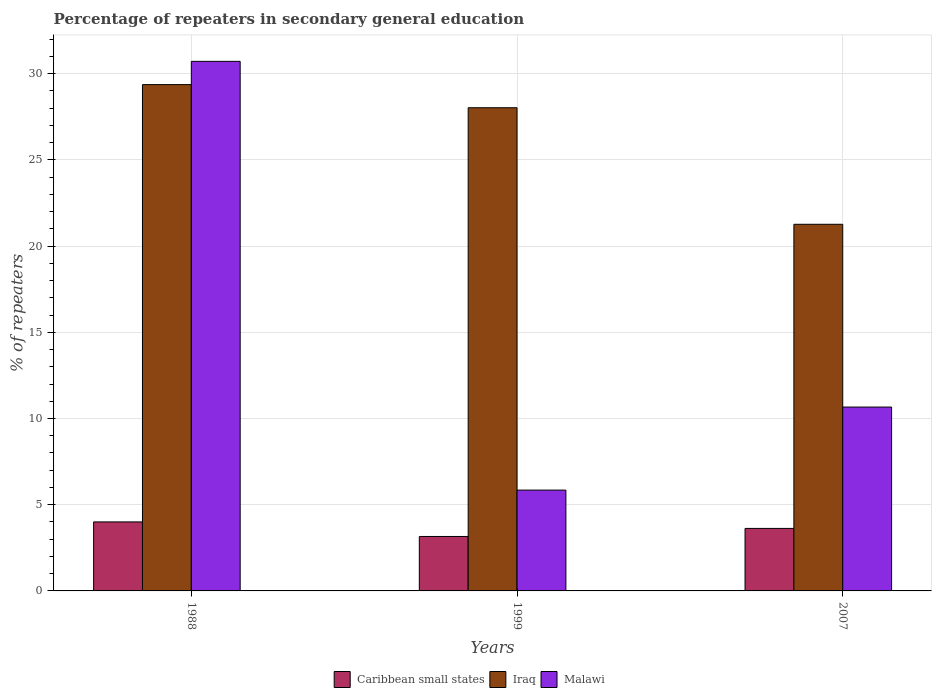Are the number of bars on each tick of the X-axis equal?
Keep it short and to the point. Yes. How many bars are there on the 1st tick from the left?
Make the answer very short. 3. How many bars are there on the 1st tick from the right?
Ensure brevity in your answer.  3. In how many cases, is the number of bars for a given year not equal to the number of legend labels?
Make the answer very short. 0. What is the percentage of repeaters in secondary general education in Iraq in 2007?
Your answer should be compact. 21.26. Across all years, what is the maximum percentage of repeaters in secondary general education in Malawi?
Offer a terse response. 30.71. Across all years, what is the minimum percentage of repeaters in secondary general education in Caribbean small states?
Your response must be concise. 3.16. What is the total percentage of repeaters in secondary general education in Malawi in the graph?
Offer a very short reply. 47.23. What is the difference between the percentage of repeaters in secondary general education in Malawi in 1999 and that in 2007?
Provide a short and direct response. -4.82. What is the difference between the percentage of repeaters in secondary general education in Caribbean small states in 1988 and the percentage of repeaters in secondary general education in Iraq in 1999?
Make the answer very short. -24.02. What is the average percentage of repeaters in secondary general education in Caribbean small states per year?
Offer a very short reply. 3.6. In the year 1988, what is the difference between the percentage of repeaters in secondary general education in Iraq and percentage of repeaters in secondary general education in Malawi?
Offer a very short reply. -1.35. In how many years, is the percentage of repeaters in secondary general education in Iraq greater than 9 %?
Offer a very short reply. 3. What is the ratio of the percentage of repeaters in secondary general education in Caribbean small states in 1988 to that in 2007?
Provide a succinct answer. 1.1. Is the difference between the percentage of repeaters in secondary general education in Iraq in 1988 and 2007 greater than the difference between the percentage of repeaters in secondary general education in Malawi in 1988 and 2007?
Provide a succinct answer. No. What is the difference between the highest and the second highest percentage of repeaters in secondary general education in Malawi?
Your answer should be compact. 20.05. What is the difference between the highest and the lowest percentage of repeaters in secondary general education in Caribbean small states?
Give a very brief answer. 0.84. What does the 1st bar from the left in 2007 represents?
Offer a terse response. Caribbean small states. What does the 1st bar from the right in 1988 represents?
Provide a succinct answer. Malawi. How many bars are there?
Provide a succinct answer. 9. How many years are there in the graph?
Give a very brief answer. 3. Are the values on the major ticks of Y-axis written in scientific E-notation?
Provide a short and direct response. No. Does the graph contain any zero values?
Provide a short and direct response. No. Where does the legend appear in the graph?
Give a very brief answer. Bottom center. How many legend labels are there?
Offer a terse response. 3. How are the legend labels stacked?
Ensure brevity in your answer.  Horizontal. What is the title of the graph?
Your answer should be very brief. Percentage of repeaters in secondary general education. Does "Solomon Islands" appear as one of the legend labels in the graph?
Your answer should be compact. No. What is the label or title of the Y-axis?
Ensure brevity in your answer.  % of repeaters. What is the % of repeaters in Caribbean small states in 1988?
Ensure brevity in your answer.  4. What is the % of repeaters of Iraq in 1988?
Ensure brevity in your answer.  29.37. What is the % of repeaters in Malawi in 1988?
Your answer should be very brief. 30.71. What is the % of repeaters of Caribbean small states in 1999?
Offer a terse response. 3.16. What is the % of repeaters of Iraq in 1999?
Make the answer very short. 28.02. What is the % of repeaters in Malawi in 1999?
Keep it short and to the point. 5.85. What is the % of repeaters in Caribbean small states in 2007?
Provide a succinct answer. 3.63. What is the % of repeaters of Iraq in 2007?
Offer a terse response. 21.26. What is the % of repeaters of Malawi in 2007?
Your answer should be very brief. 10.66. Across all years, what is the maximum % of repeaters in Caribbean small states?
Make the answer very short. 4. Across all years, what is the maximum % of repeaters of Iraq?
Give a very brief answer. 29.37. Across all years, what is the maximum % of repeaters of Malawi?
Offer a terse response. 30.71. Across all years, what is the minimum % of repeaters of Caribbean small states?
Provide a succinct answer. 3.16. Across all years, what is the minimum % of repeaters of Iraq?
Your answer should be very brief. 21.26. Across all years, what is the minimum % of repeaters of Malawi?
Give a very brief answer. 5.85. What is the total % of repeaters of Caribbean small states in the graph?
Provide a succinct answer. 10.79. What is the total % of repeaters of Iraq in the graph?
Your response must be concise. 78.66. What is the total % of repeaters in Malawi in the graph?
Your answer should be compact. 47.23. What is the difference between the % of repeaters of Caribbean small states in 1988 and that in 1999?
Offer a very short reply. 0.84. What is the difference between the % of repeaters of Iraq in 1988 and that in 1999?
Your answer should be compact. 1.34. What is the difference between the % of repeaters of Malawi in 1988 and that in 1999?
Offer a terse response. 24.87. What is the difference between the % of repeaters in Caribbean small states in 1988 and that in 2007?
Provide a short and direct response. 0.38. What is the difference between the % of repeaters of Iraq in 1988 and that in 2007?
Provide a short and direct response. 8.1. What is the difference between the % of repeaters of Malawi in 1988 and that in 2007?
Provide a succinct answer. 20.05. What is the difference between the % of repeaters of Caribbean small states in 1999 and that in 2007?
Offer a terse response. -0.47. What is the difference between the % of repeaters in Iraq in 1999 and that in 2007?
Your answer should be compact. 6.76. What is the difference between the % of repeaters of Malawi in 1999 and that in 2007?
Make the answer very short. -4.82. What is the difference between the % of repeaters of Caribbean small states in 1988 and the % of repeaters of Iraq in 1999?
Provide a short and direct response. -24.02. What is the difference between the % of repeaters of Caribbean small states in 1988 and the % of repeaters of Malawi in 1999?
Your response must be concise. -1.84. What is the difference between the % of repeaters in Iraq in 1988 and the % of repeaters in Malawi in 1999?
Offer a terse response. 23.52. What is the difference between the % of repeaters of Caribbean small states in 1988 and the % of repeaters of Iraq in 2007?
Give a very brief answer. -17.26. What is the difference between the % of repeaters of Caribbean small states in 1988 and the % of repeaters of Malawi in 2007?
Give a very brief answer. -6.66. What is the difference between the % of repeaters in Iraq in 1988 and the % of repeaters in Malawi in 2007?
Your answer should be compact. 18.7. What is the difference between the % of repeaters of Caribbean small states in 1999 and the % of repeaters of Iraq in 2007?
Offer a very short reply. -18.11. What is the difference between the % of repeaters in Caribbean small states in 1999 and the % of repeaters in Malawi in 2007?
Provide a succinct answer. -7.51. What is the difference between the % of repeaters in Iraq in 1999 and the % of repeaters in Malawi in 2007?
Make the answer very short. 17.36. What is the average % of repeaters in Caribbean small states per year?
Your answer should be compact. 3.6. What is the average % of repeaters in Iraq per year?
Offer a terse response. 26.22. What is the average % of repeaters in Malawi per year?
Provide a short and direct response. 15.74. In the year 1988, what is the difference between the % of repeaters in Caribbean small states and % of repeaters in Iraq?
Give a very brief answer. -25.36. In the year 1988, what is the difference between the % of repeaters in Caribbean small states and % of repeaters in Malawi?
Provide a short and direct response. -26.71. In the year 1988, what is the difference between the % of repeaters of Iraq and % of repeaters of Malawi?
Offer a terse response. -1.35. In the year 1999, what is the difference between the % of repeaters in Caribbean small states and % of repeaters in Iraq?
Offer a very short reply. -24.87. In the year 1999, what is the difference between the % of repeaters of Caribbean small states and % of repeaters of Malawi?
Ensure brevity in your answer.  -2.69. In the year 1999, what is the difference between the % of repeaters in Iraq and % of repeaters in Malawi?
Give a very brief answer. 22.18. In the year 2007, what is the difference between the % of repeaters of Caribbean small states and % of repeaters of Iraq?
Your answer should be compact. -17.64. In the year 2007, what is the difference between the % of repeaters of Caribbean small states and % of repeaters of Malawi?
Offer a very short reply. -7.04. In the year 2007, what is the difference between the % of repeaters of Iraq and % of repeaters of Malawi?
Provide a succinct answer. 10.6. What is the ratio of the % of repeaters of Caribbean small states in 1988 to that in 1999?
Ensure brevity in your answer.  1.27. What is the ratio of the % of repeaters in Iraq in 1988 to that in 1999?
Offer a terse response. 1.05. What is the ratio of the % of repeaters of Malawi in 1988 to that in 1999?
Give a very brief answer. 5.25. What is the ratio of the % of repeaters in Caribbean small states in 1988 to that in 2007?
Give a very brief answer. 1.1. What is the ratio of the % of repeaters of Iraq in 1988 to that in 2007?
Your answer should be very brief. 1.38. What is the ratio of the % of repeaters in Malawi in 1988 to that in 2007?
Your answer should be compact. 2.88. What is the ratio of the % of repeaters of Caribbean small states in 1999 to that in 2007?
Provide a short and direct response. 0.87. What is the ratio of the % of repeaters in Iraq in 1999 to that in 2007?
Your answer should be very brief. 1.32. What is the ratio of the % of repeaters in Malawi in 1999 to that in 2007?
Your answer should be compact. 0.55. What is the difference between the highest and the second highest % of repeaters of Caribbean small states?
Your answer should be very brief. 0.38. What is the difference between the highest and the second highest % of repeaters of Iraq?
Provide a short and direct response. 1.34. What is the difference between the highest and the second highest % of repeaters in Malawi?
Your response must be concise. 20.05. What is the difference between the highest and the lowest % of repeaters in Caribbean small states?
Ensure brevity in your answer.  0.84. What is the difference between the highest and the lowest % of repeaters in Iraq?
Offer a terse response. 8.1. What is the difference between the highest and the lowest % of repeaters in Malawi?
Your answer should be very brief. 24.87. 